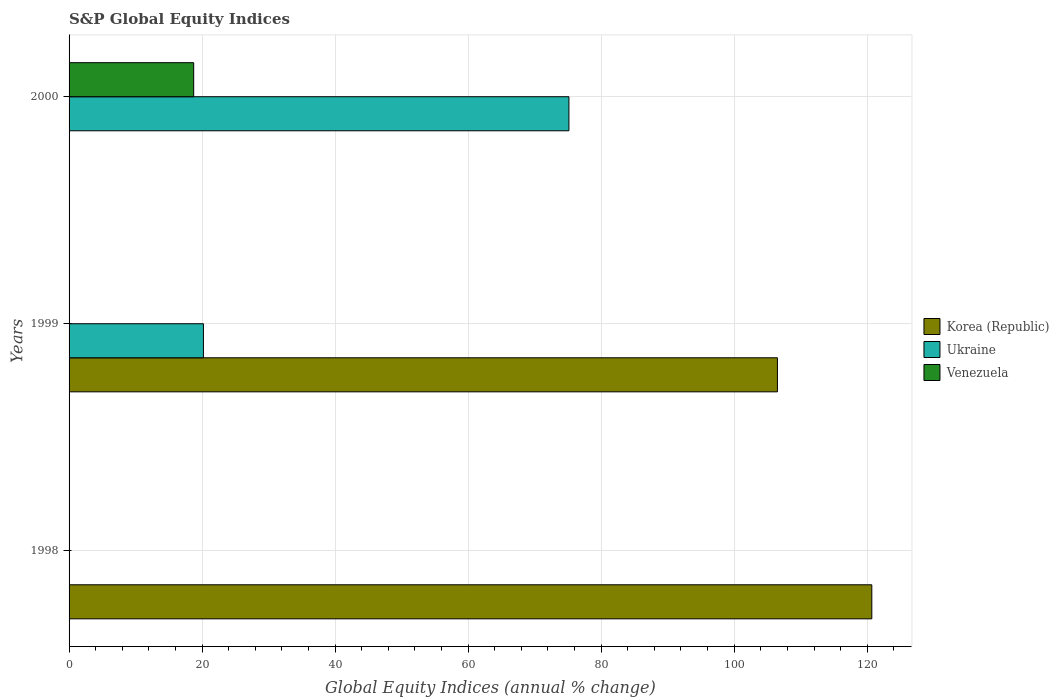Are the number of bars per tick equal to the number of legend labels?
Your response must be concise. No. Are the number of bars on each tick of the Y-axis equal?
Your answer should be compact. No. What is the global equity indices in Ukraine in 2000?
Offer a very short reply. 75.15. Across all years, what is the maximum global equity indices in Venezuela?
Your answer should be compact. 18.74. Across all years, what is the minimum global equity indices in Venezuela?
Your response must be concise. 0. What is the total global equity indices in Ukraine in the graph?
Make the answer very short. 95.35. What is the difference between the global equity indices in Ukraine in 1999 and that in 2000?
Your answer should be very brief. -54.95. What is the difference between the global equity indices in Korea (Republic) in 2000 and the global equity indices in Ukraine in 1999?
Your response must be concise. -20.2. What is the average global equity indices in Venezuela per year?
Offer a terse response. 6.25. In the year 1999, what is the difference between the global equity indices in Korea (Republic) and global equity indices in Ukraine?
Offer a terse response. 86.3. In how many years, is the global equity indices in Venezuela greater than 48 %?
Offer a very short reply. 0. What is the ratio of the global equity indices in Korea (Republic) in 1998 to that in 1999?
Make the answer very short. 1.13. Is the global equity indices in Ukraine in 1999 less than that in 2000?
Give a very brief answer. Yes. What is the difference between the highest and the lowest global equity indices in Ukraine?
Offer a very short reply. 75.15. In how many years, is the global equity indices in Ukraine greater than the average global equity indices in Ukraine taken over all years?
Offer a very short reply. 1. Is it the case that in every year, the sum of the global equity indices in Korea (Republic) and global equity indices in Venezuela is greater than the global equity indices in Ukraine?
Give a very brief answer. No. How many bars are there?
Keep it short and to the point. 5. How many years are there in the graph?
Ensure brevity in your answer.  3. What is the difference between two consecutive major ticks on the X-axis?
Offer a very short reply. 20. Are the values on the major ticks of X-axis written in scientific E-notation?
Your answer should be compact. No. What is the title of the graph?
Make the answer very short. S&P Global Equity Indices. Does "Northern Mariana Islands" appear as one of the legend labels in the graph?
Offer a very short reply. No. What is the label or title of the X-axis?
Give a very brief answer. Global Equity Indices (annual % change). What is the Global Equity Indices (annual % change) of Korea (Republic) in 1998?
Offer a terse response. 120.69. What is the Global Equity Indices (annual % change) in Venezuela in 1998?
Your response must be concise. 0. What is the Global Equity Indices (annual % change) of Korea (Republic) in 1999?
Keep it short and to the point. 106.5. What is the Global Equity Indices (annual % change) of Ukraine in 1999?
Your response must be concise. 20.2. What is the Global Equity Indices (annual % change) in Korea (Republic) in 2000?
Ensure brevity in your answer.  0. What is the Global Equity Indices (annual % change) in Ukraine in 2000?
Your answer should be very brief. 75.15. What is the Global Equity Indices (annual % change) of Venezuela in 2000?
Provide a short and direct response. 18.74. Across all years, what is the maximum Global Equity Indices (annual % change) in Korea (Republic)?
Make the answer very short. 120.69. Across all years, what is the maximum Global Equity Indices (annual % change) of Ukraine?
Make the answer very short. 75.15. Across all years, what is the maximum Global Equity Indices (annual % change) in Venezuela?
Provide a succinct answer. 18.74. Across all years, what is the minimum Global Equity Indices (annual % change) of Korea (Republic)?
Offer a terse response. 0. What is the total Global Equity Indices (annual % change) of Korea (Republic) in the graph?
Your answer should be compact. 227.19. What is the total Global Equity Indices (annual % change) of Ukraine in the graph?
Make the answer very short. 95.35. What is the total Global Equity Indices (annual % change) in Venezuela in the graph?
Your response must be concise. 18.74. What is the difference between the Global Equity Indices (annual % change) of Korea (Republic) in 1998 and that in 1999?
Give a very brief answer. 14.19. What is the difference between the Global Equity Indices (annual % change) of Ukraine in 1999 and that in 2000?
Give a very brief answer. -54.95. What is the difference between the Global Equity Indices (annual % change) of Korea (Republic) in 1998 and the Global Equity Indices (annual % change) of Ukraine in 1999?
Give a very brief answer. 100.49. What is the difference between the Global Equity Indices (annual % change) in Korea (Republic) in 1998 and the Global Equity Indices (annual % change) in Ukraine in 2000?
Ensure brevity in your answer.  45.54. What is the difference between the Global Equity Indices (annual % change) in Korea (Republic) in 1998 and the Global Equity Indices (annual % change) in Venezuela in 2000?
Your answer should be very brief. 101.96. What is the difference between the Global Equity Indices (annual % change) in Korea (Republic) in 1999 and the Global Equity Indices (annual % change) in Ukraine in 2000?
Provide a short and direct response. 31.35. What is the difference between the Global Equity Indices (annual % change) of Korea (Republic) in 1999 and the Global Equity Indices (annual % change) of Venezuela in 2000?
Your answer should be compact. 87.76. What is the difference between the Global Equity Indices (annual % change) in Ukraine in 1999 and the Global Equity Indices (annual % change) in Venezuela in 2000?
Your answer should be very brief. 1.46. What is the average Global Equity Indices (annual % change) in Korea (Republic) per year?
Your answer should be compact. 75.73. What is the average Global Equity Indices (annual % change) of Ukraine per year?
Keep it short and to the point. 31.78. What is the average Global Equity Indices (annual % change) in Venezuela per year?
Provide a succinct answer. 6.25. In the year 1999, what is the difference between the Global Equity Indices (annual % change) of Korea (Republic) and Global Equity Indices (annual % change) of Ukraine?
Provide a succinct answer. 86.3. In the year 2000, what is the difference between the Global Equity Indices (annual % change) of Ukraine and Global Equity Indices (annual % change) of Venezuela?
Keep it short and to the point. 56.42. What is the ratio of the Global Equity Indices (annual % change) of Korea (Republic) in 1998 to that in 1999?
Offer a very short reply. 1.13. What is the ratio of the Global Equity Indices (annual % change) of Ukraine in 1999 to that in 2000?
Your answer should be compact. 0.27. What is the difference between the highest and the lowest Global Equity Indices (annual % change) of Korea (Republic)?
Ensure brevity in your answer.  120.69. What is the difference between the highest and the lowest Global Equity Indices (annual % change) in Ukraine?
Ensure brevity in your answer.  75.15. What is the difference between the highest and the lowest Global Equity Indices (annual % change) of Venezuela?
Your response must be concise. 18.74. 